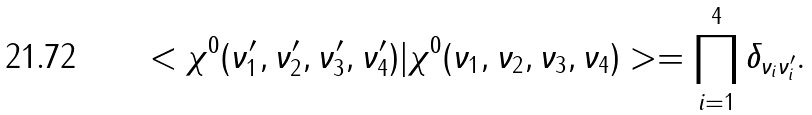Convert formula to latex. <formula><loc_0><loc_0><loc_500><loc_500>< \chi ^ { 0 } ( \nu _ { 1 } ^ { \prime } , \nu _ { 2 } ^ { \prime } , \nu _ { 3 } ^ { \prime } , \nu _ { 4 } ^ { \prime } ) | \chi ^ { 0 } ( \nu _ { 1 } , \nu _ { 2 } , \nu _ { 3 } , \nu _ { 4 } ) > = \prod _ { i = 1 } ^ { 4 } \delta _ { \nu _ { i } \nu _ { i } ^ { \prime } } .</formula> 